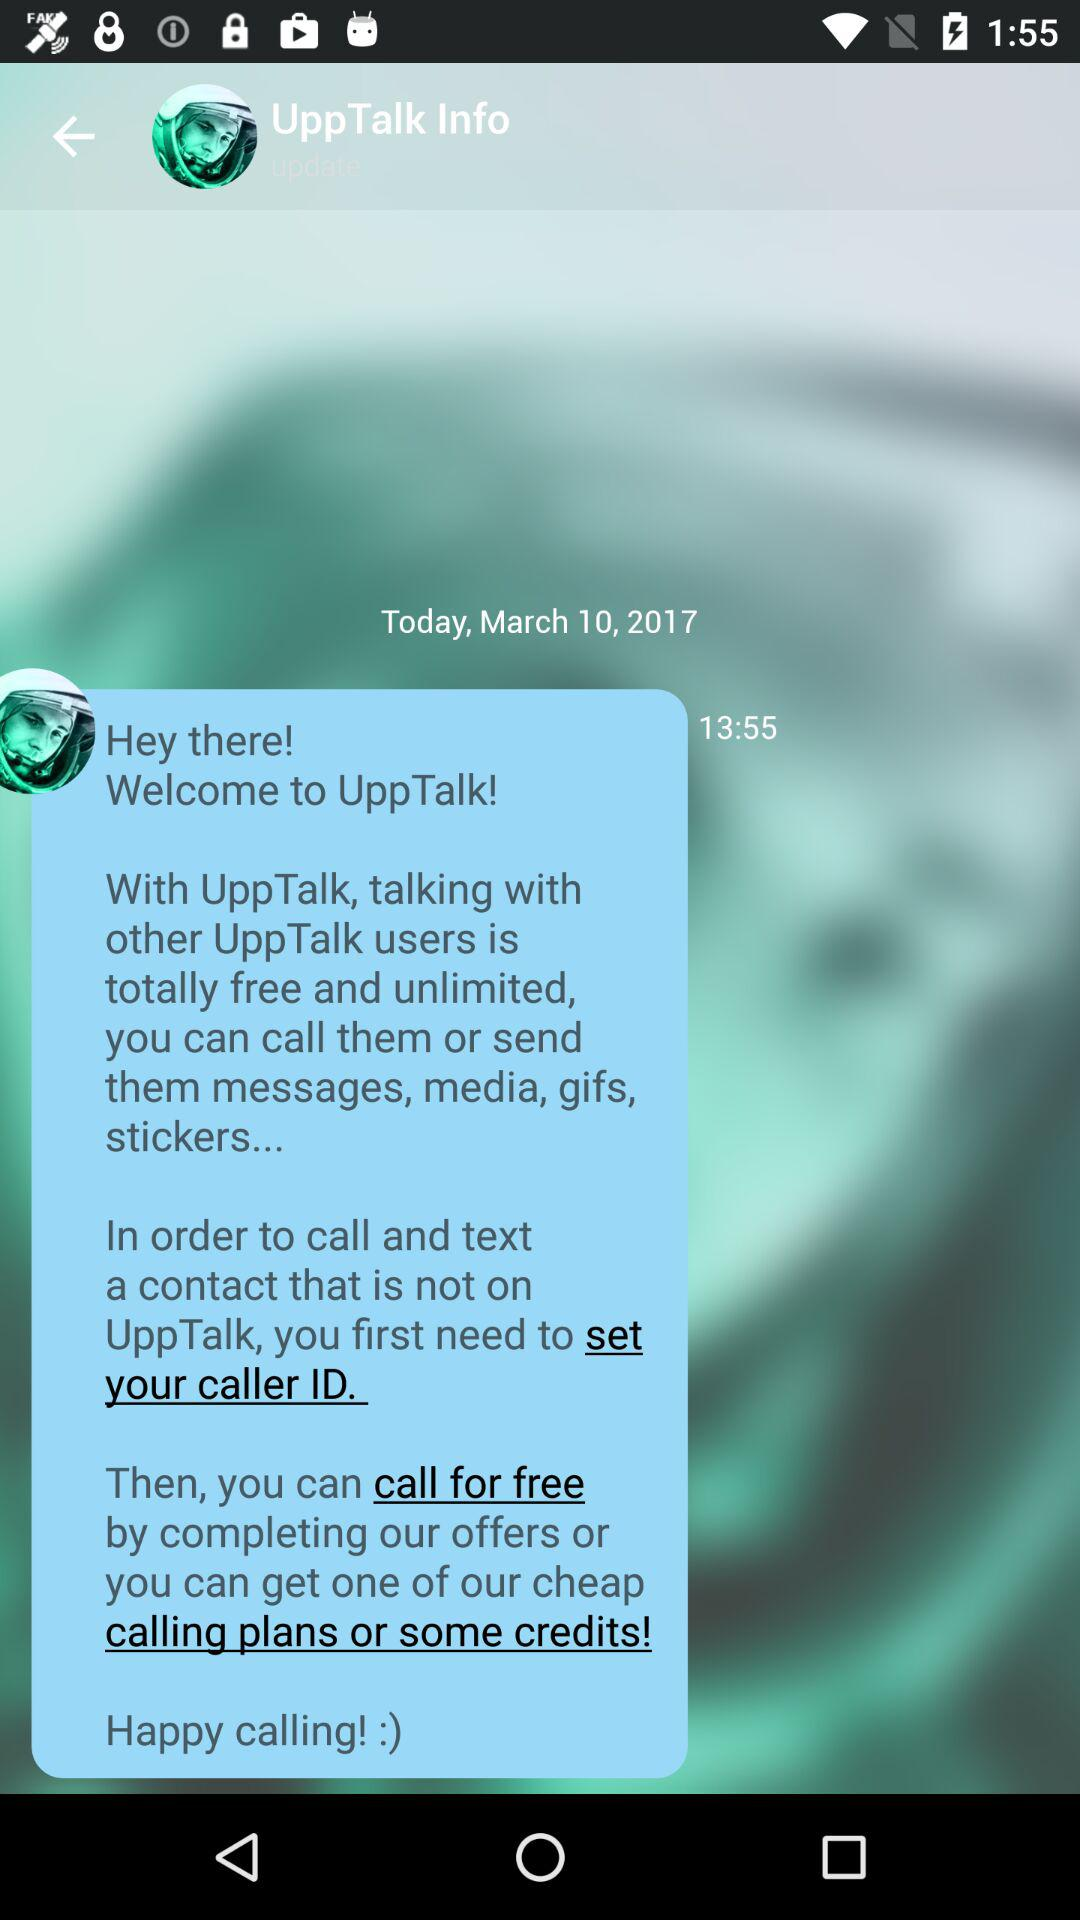What is the app name? The app name is "UppTalk". 